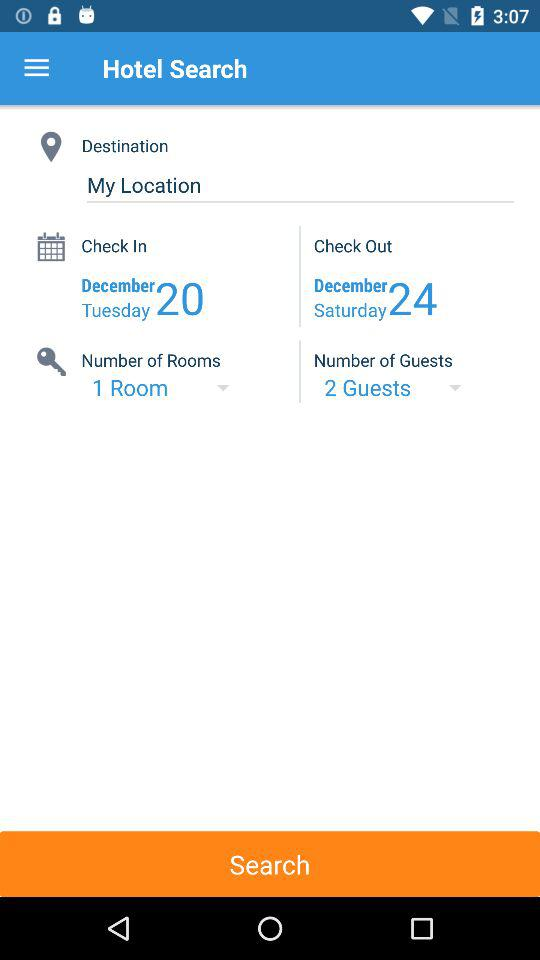How many more guests are there than rooms?
Answer the question using a single word or phrase. 1 